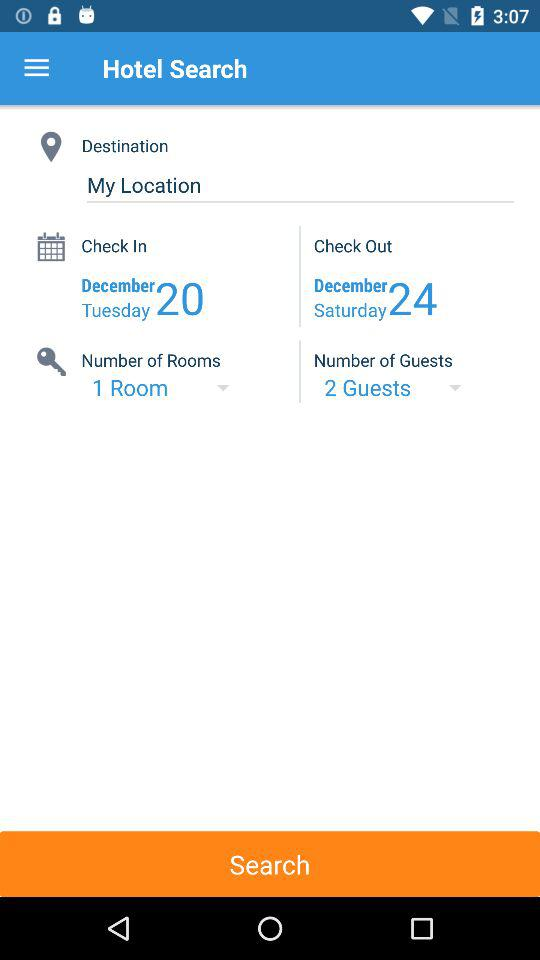How many more guests are there than rooms?
Answer the question using a single word or phrase. 1 